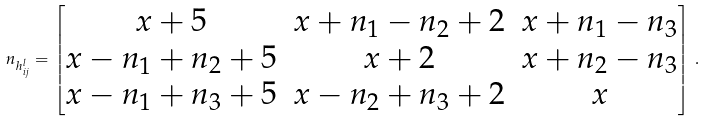Convert formula to latex. <formula><loc_0><loc_0><loc_500><loc_500>n _ { h ^ { l } _ { i j } } = \begin{bmatrix} x + 5 & x + n _ { 1 } - n _ { 2 } + 2 & x + n _ { 1 } - n _ { 3 } \\ x - n _ { 1 } + n _ { 2 } + 5 & x + 2 & x + n _ { 2 } - n _ { 3 } \\ x - n _ { 1 } + n _ { 3 } + 5 & x - n _ { 2 } + n _ { 3 } + 2 & x \end{bmatrix} \, .</formula> 